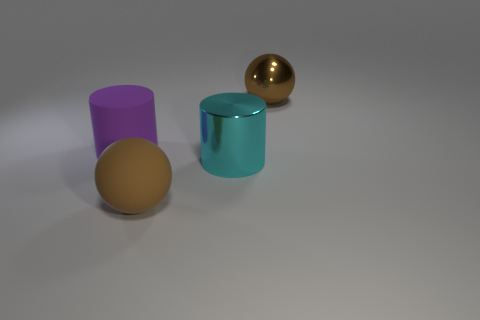What material is the other sphere that is the same color as the large metallic ball?
Give a very brief answer. Rubber. How many metallic objects are either tiny blue blocks or cyan cylinders?
Keep it short and to the point. 1. How many objects are big things or things on the left side of the large brown metallic sphere?
Provide a succinct answer. 4. How many other things are there of the same color as the big shiny sphere?
Offer a terse response. 1. There is a shiny sphere; does it have the same size as the object left of the large matte sphere?
Provide a short and direct response. Yes. How many other things are the same material as the cyan object?
Ensure brevity in your answer.  1. Are there the same number of objects that are behind the big metallic ball and big purple cylinders that are behind the big purple matte cylinder?
Provide a succinct answer. Yes. What is the color of the ball that is in front of the matte object that is to the left of the large brown ball in front of the big brown metallic ball?
Make the answer very short. Brown. There is a purple thing that is behind the cyan metal thing; what is its shape?
Provide a short and direct response. Cylinder. There is a object that is the same material as the purple cylinder; what is its shape?
Keep it short and to the point. Sphere. 